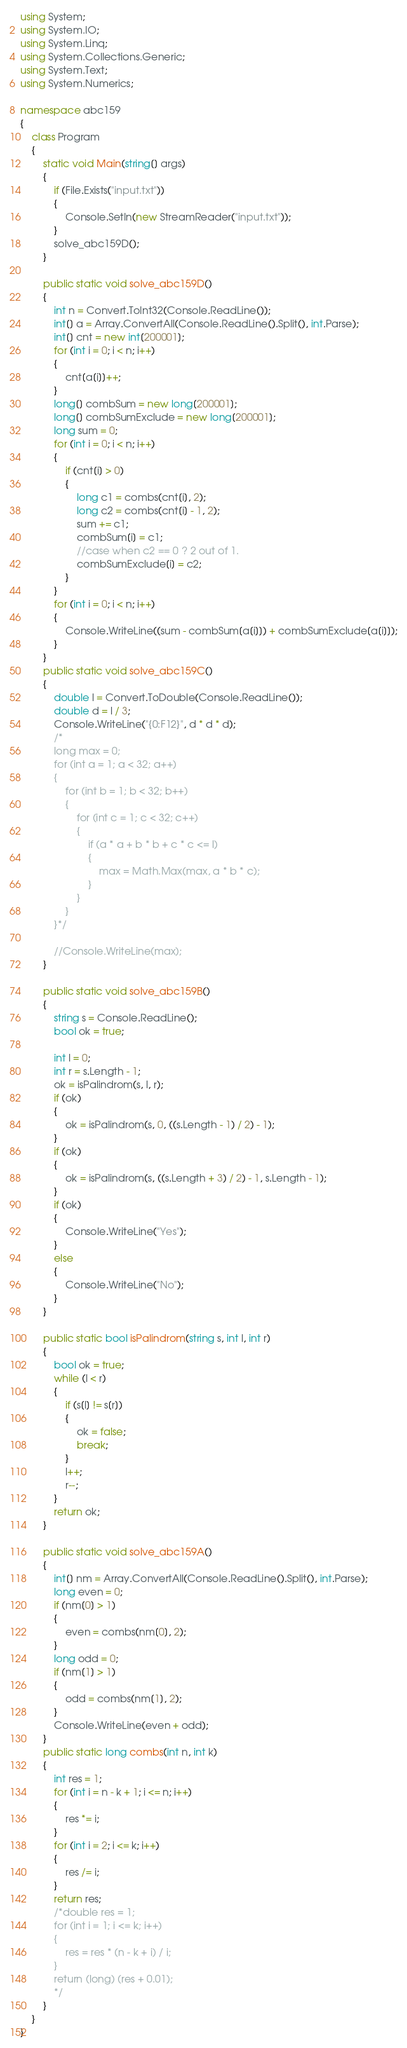<code> <loc_0><loc_0><loc_500><loc_500><_C#_>using System;
using System.IO;
using System.Linq;
using System.Collections.Generic;
using System.Text;
using System.Numerics;

namespace abc159
{
    class Program
    {
        static void Main(string[] args)
        {
            if (File.Exists("input.txt"))
            {
                Console.SetIn(new StreamReader("input.txt"));
            }
			solve_abc159D();
        }

        public static void solve_abc159D()
        {
            int n = Convert.ToInt32(Console.ReadLine());
            int[] a = Array.ConvertAll(Console.ReadLine().Split(), int.Parse);
            int[] cnt = new int[200001];
            for (int i = 0; i < n; i++)
            {
                cnt[a[i]]++;
            }
            long[] combSum = new long[200001];
            long[] combSumExclude = new long[200001];
            long sum = 0;
            for (int i = 0; i < n; i++)
            {
                if (cnt[i] > 0)
                {
                    long c1 = combs(cnt[i], 2);
                    long c2 = combs(cnt[i] - 1, 2);
                    sum += c1;
                    combSum[i] = c1;
                    //case when c2 == 0 ? 2 out of 1.
                    combSumExclude[i] = c2;
                }
            }
            for (int i = 0; i < n; i++)
            {
                Console.WriteLine((sum - combSum[a[i]]) + combSumExclude[a[i]]);
            }
        }
        public static void solve_abc159C()
        {
            double l = Convert.ToDouble(Console.ReadLine());
            double d = l / 3;
            Console.WriteLine("{0:F12}", d * d * d);
            /*
            long max = 0; 
            for (int a = 1; a < 32; a++)
            {
                for (int b = 1; b < 32; b++)
                {
                    for (int c = 1; c < 32; c++)
                    {
                        if (a * a + b * b + c * c <= l)
                        {
                            max = Math.Max(max, a * b * c);
                        }
                    }
                }
            }*/

            //Console.WriteLine(max);
        }

        public static void solve_abc159B()
        {
            string s = Console.ReadLine();
            bool ok = true;

            int l = 0;
            int r = s.Length - 1;
            ok = isPalindrom(s, l, r);
            if (ok)
            {
                ok = isPalindrom(s, 0, ((s.Length - 1) / 2) - 1);
            }
            if (ok)
            {
                ok = isPalindrom(s, ((s.Length + 3) / 2) - 1, s.Length - 1);
            }
            if (ok)
            {
                Console.WriteLine("Yes");
            }
            else
            {
                Console.WriteLine("No");
            }
        }

        public static bool isPalindrom(string s, int l, int r)
        {
            bool ok = true;
            while (l < r)
            {
                if (s[l] != s[r])
                {
                    ok = false;
                    break;
                }
                l++;
                r--;
            }
            return ok;
        }

        public static void solve_abc159A()
        {
            int[] nm = Array.ConvertAll(Console.ReadLine().Split(), int.Parse);
            long even = 0;
            if (nm[0] > 1)
            {
                even = combs(nm[0], 2);
            }
            long odd = 0;
            if (nm[1] > 1)
            {
                odd = combs(nm[1], 2);
            }
            Console.WriteLine(even + odd);
        }
        public static long combs(int n, int k)
        {
	        int res = 1;
	        for (int i = n - k + 1; i <= n; i++)
            {
		        res *= i;
            }
	        for (int i = 2; i <= k; i++)
            {
		        res /= i;
            }
            return res;
            /*double res = 1;
	        for (int i = 1; i <= k; i++)
            {
		        res = res * (n - k + i) / i;
            }
	        return (long) (res + 0.01);
            */
        }
    }
}
</code> 